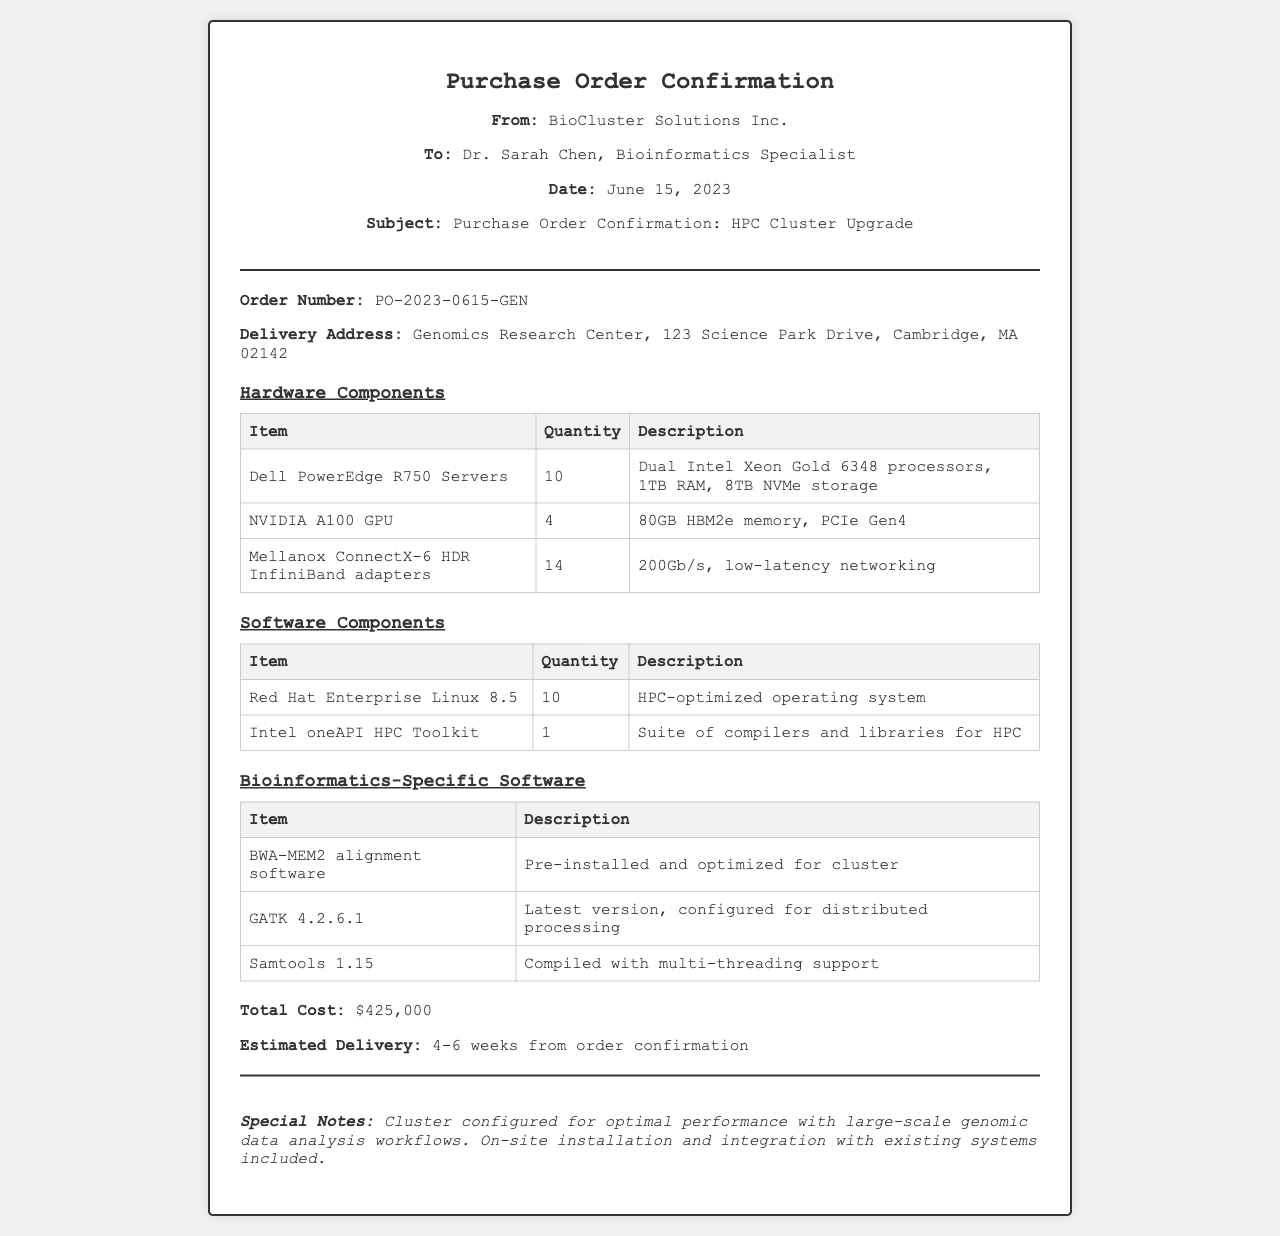What is the order number? The order number is mentioned in the order details section of the document as PO-2023-0615-GEN.
Answer: PO-2023-0615-GEN Who is the order addressed to? The document states that the order is addressed to Dr. Sarah Chen, a Bioinformatics Specialist.
Answer: Dr. Sarah Chen What type of servers are being ordered? The document specifies that Dell PowerEdge R750 Servers are part of the order under hardware components.
Answer: Dell PowerEdge R750 Servers How many NVIDIA A100 GPUs are included in the order? The document lists that 4 NVIDIA A100 GPUs are included under the hardware components.
Answer: 4 What is the total cost of the order? The total cost is clearly stated at the bottom of the document as $425,000.
Answer: $425,000 What software is pre-installed and optimized for the cluster? The document mentions BWA-MEM2 alignment software as being pre-installed and optimized.
Answer: BWA-MEM2 alignment software What is the estimated delivery time? The estimated delivery time is stated as 4-6 weeks from order confirmation.
Answer: 4-6 weeks Is on-site installation included in the purchase? The footer section of the document indicates that on-site installation and integration with existing systems is included.
Answer: Yes What is the total number of Dell PowerEdge R750 Servers being ordered? The hardware components table shows that 10 Dell PowerEdge R750 Servers are included in the order.
Answer: 10 